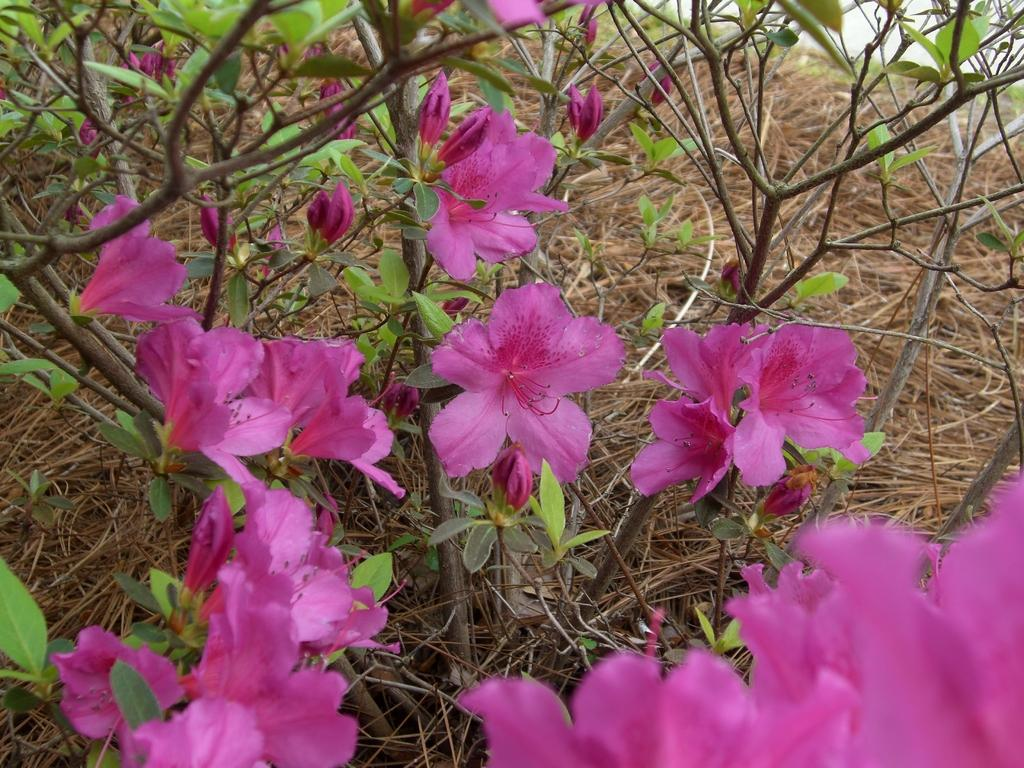What type of living organisms can be seen in the image? Plants can be seen in the image. What colors are present on the plants? The plants have green and brown colors. What additional features can be observed on the plants? There are flowers on the plants. What color are the flowers? The flowers have a pink color. What can be seen in the background of the image? Grass and the sky are visible in the background of the image. How many queens are sitting on the grass in the image? There are no queens present in the image; it features plants with flowers and a grassy background. 